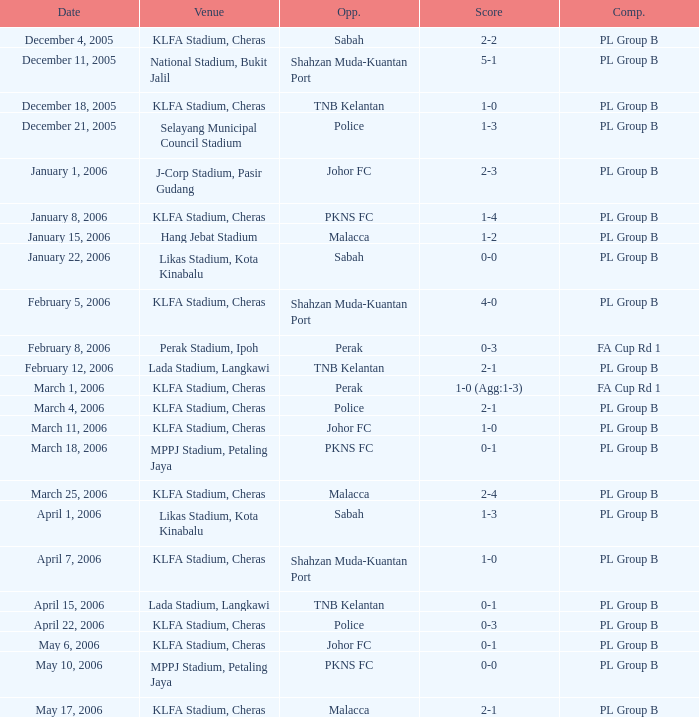Which Competition has Opponents of pkns fc, and a Score of 0-0? PL Group B. 